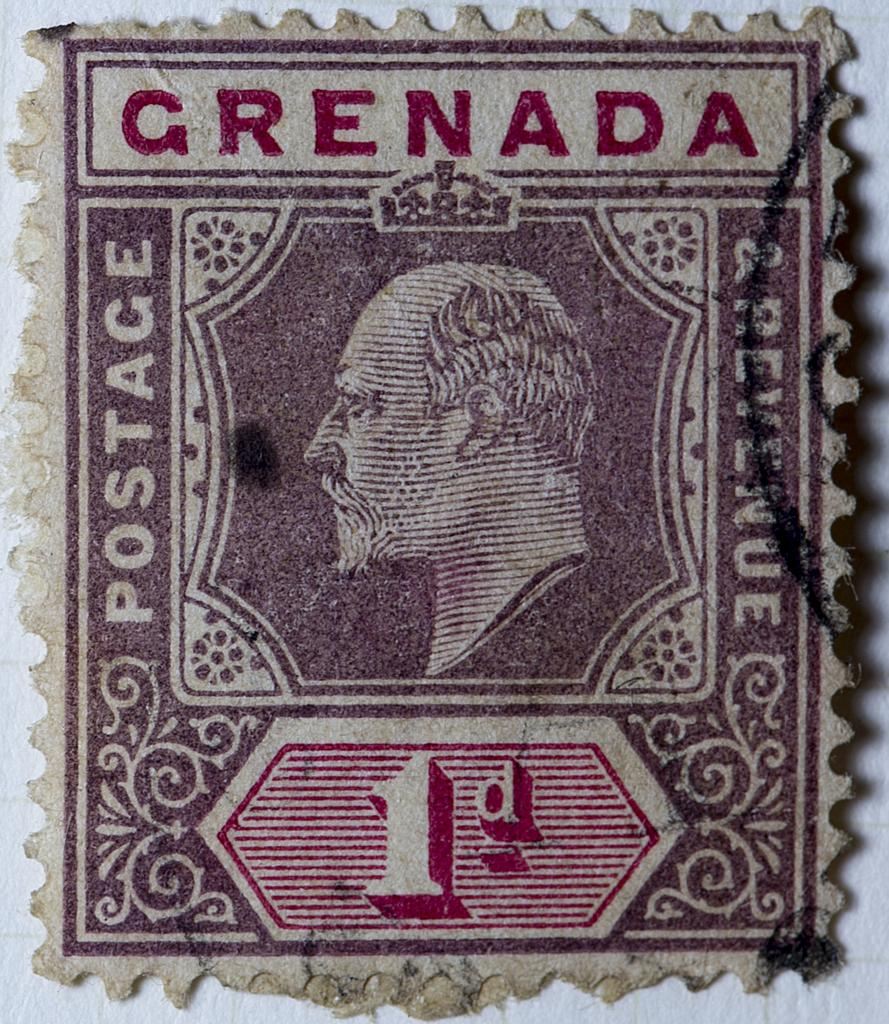What is the main object in the image? There is a stamp sticker in the image. What is on the stamp sticker? Something is written on the stamp sticker. What color is the writing on the stamp sticker? The writing on the stamp sticker is in red color. What is the condition of the news in the image? There is no news present in the image; it only features a stamp sticker with red writing. 